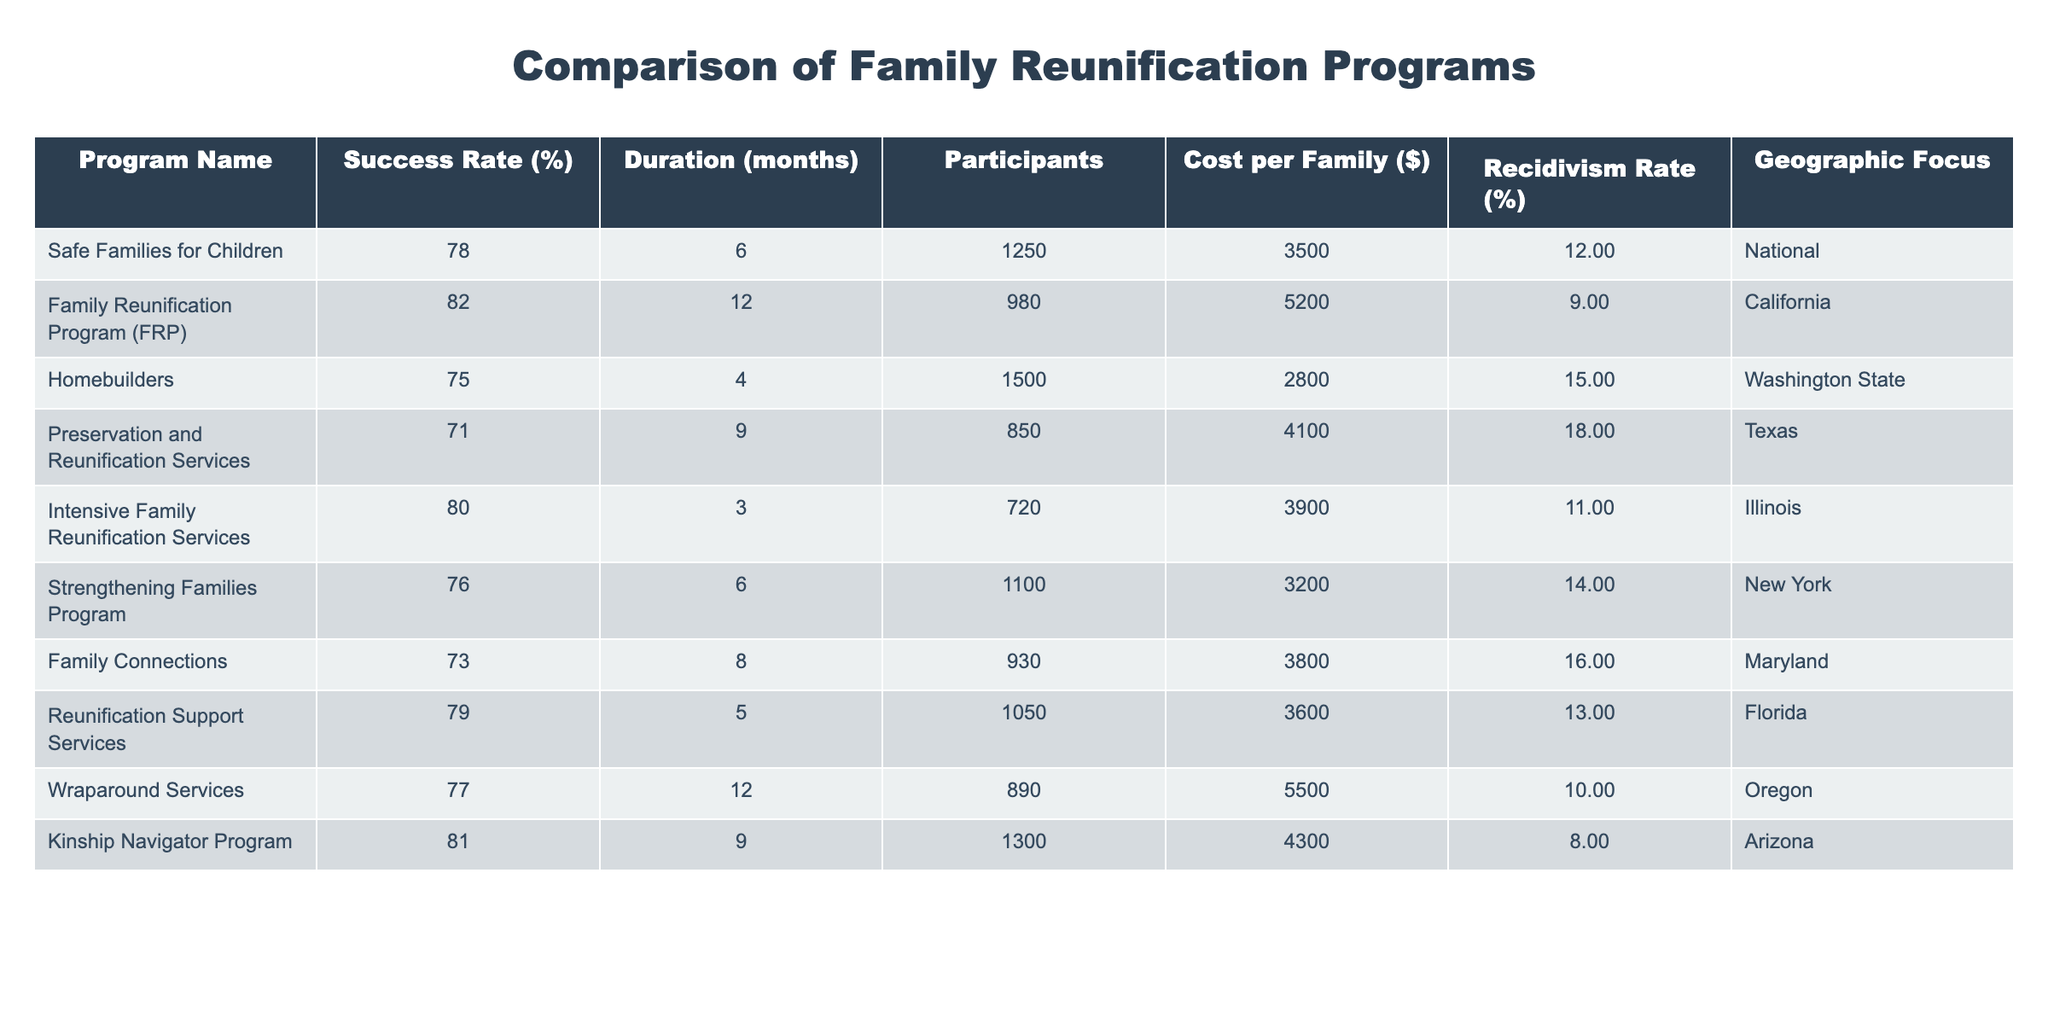What is the success rate of the Family Reunification Program? The success rate of the Family Reunification Program (FRP) is explicitly stated in the table as 82%.
Answer: 82% Which program has the lowest recidivism rate? The program with the lowest recidivism rate is the Kinship Navigator Program, which has a recidivism rate of 8%.
Answer: Kinship Navigator Program What is the average success rate of all the programs listed? To find the average success rate, sum all the success rates: (78 + 82 + 75 + 71 + 80 + 76 + 73 + 79 + 77 + 81) =  78.1 and divide by the number of programs (10), which results in an average of 78.1%.
Answer: 78.1% Is the cost per family for the Homebuilders program less than the average cost per family? The Homebuilders program has a cost of 2800 per family. To find the average cost per family, sum all costs: (3500 + 5200 + 2800 + 4100 + 3900 + 3200 + 3800 + 3600 + 5500 + 4300) = 41000 and divide by 10, which gives an average of 4100. Since 2800 is less than 4100, the answer is yes.
Answer: Yes What is the difference in success rate between the program with the highest and the program with the lowest success rate? The program with the highest success rate is the FRP at 82%, and the lowest is the Preservation and Reunification Services at 71%. The difference is calculated as 82 - 71 = 11%.
Answer: 11% Which program is focused on Arizona and what is its success rate? The program focused on Arizona is the Kinship Navigator Program, and its success rate is 81%.
Answer: Kinship Navigator Program, 81% How many participants are there in Strengthening Families Program? The number of participants in the Strengthening Families Program is explicitly provided in the table as 1100.
Answer: 1100 Which program has a duration of 6 months and what is its success rate? The programs with a duration of 6 months are Safe Families for Children and Strengthening Families Program. Their success rates are 78% and 76% respectively.
Answer: Safe Families for Children - 78%, Strengthening Families Program - 76% 